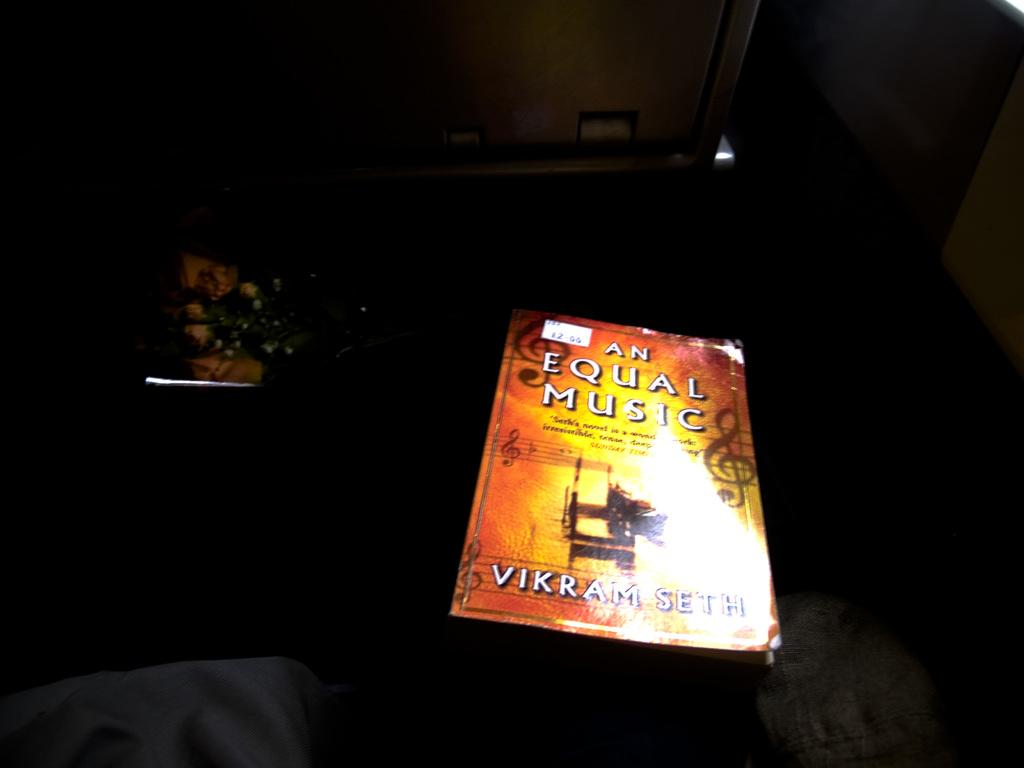<image>
Provide a brief description of the given image. A dark area with a light shining on An Equal Music, a book by Vikram Seth. 